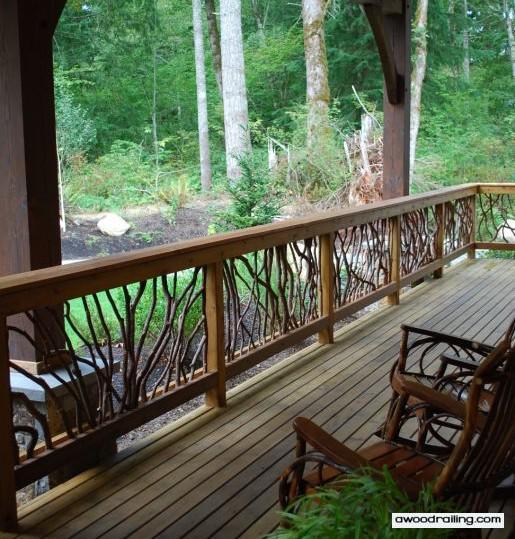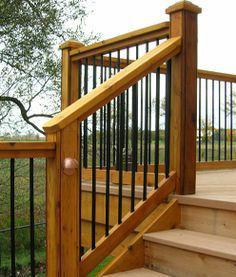The first image is the image on the left, the second image is the image on the right. Examine the images to the left and right. Is the description "In at least one image there are at least 4 steps facing forward right at the bottom of the balcony." accurate? Answer yes or no. No. 